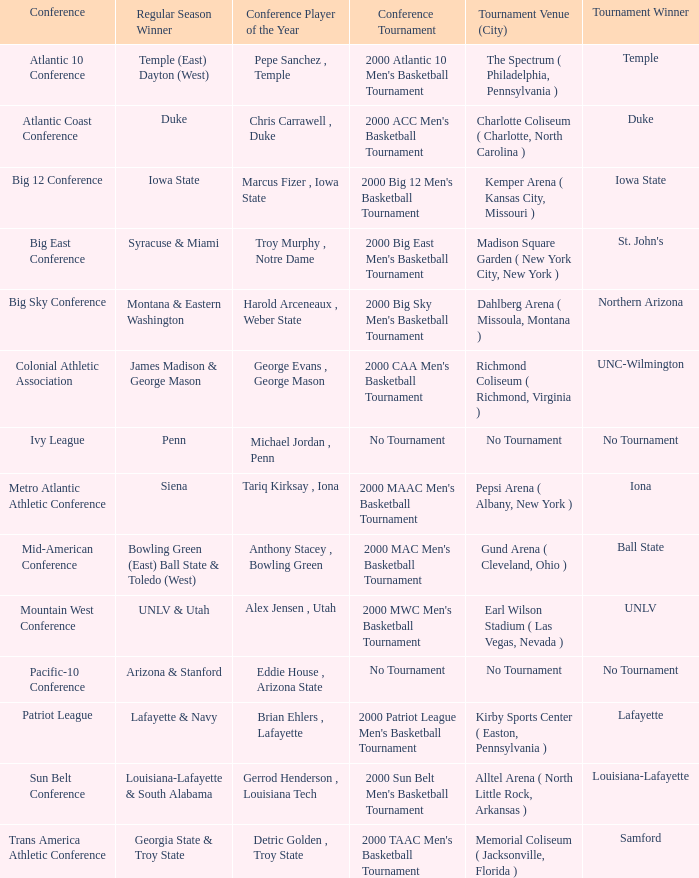How many players of the year are there in the Mountain West Conference? 1.0. 